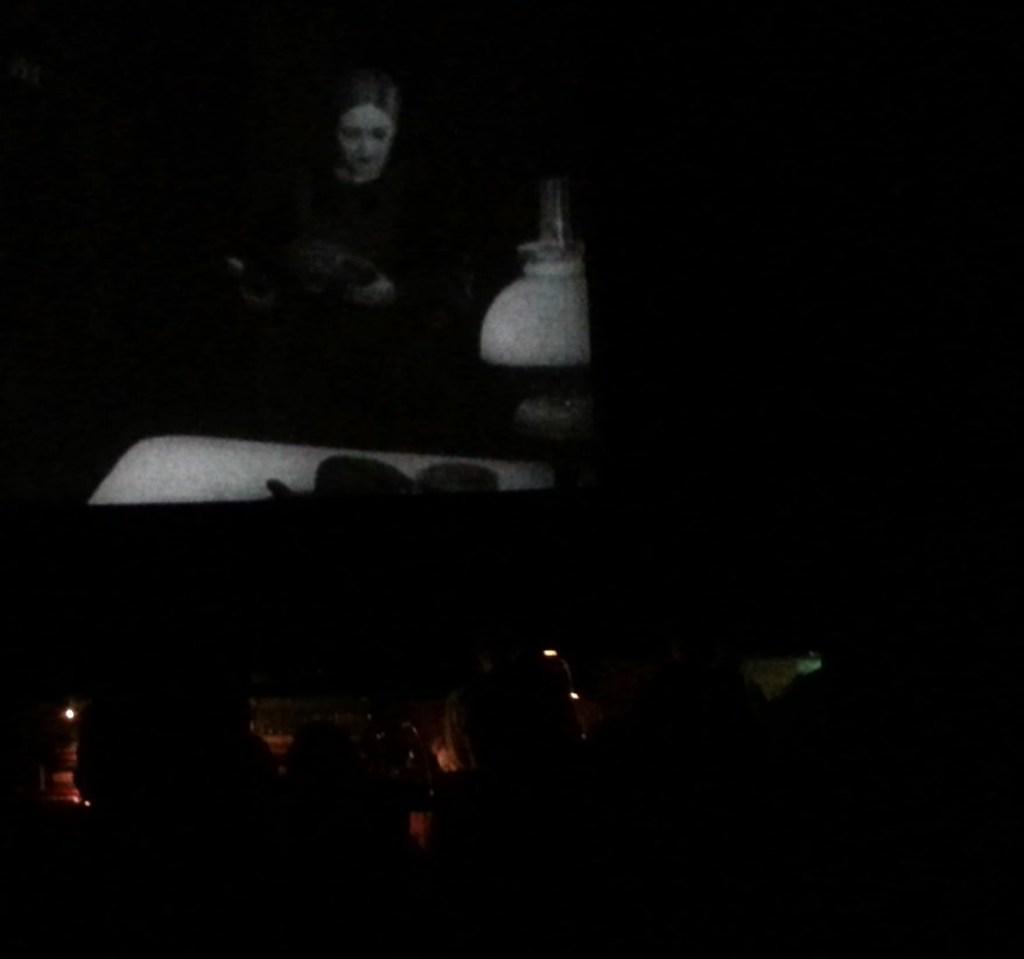In one or two sentences, can you explain what this image depicts? In this image there are persons sitting in a cinema hall in the front. In the center there is a screen in which the cinema is playing. 